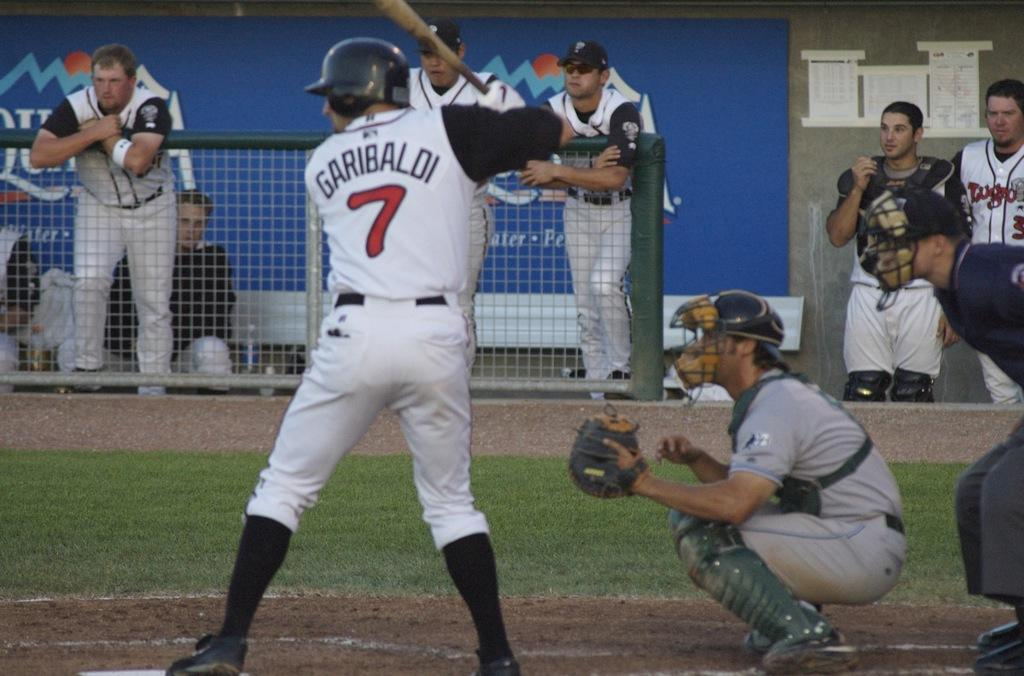<image>
Provide a brief description of the given image. A batter in a white jersey named Garibaldi with the number 7. 